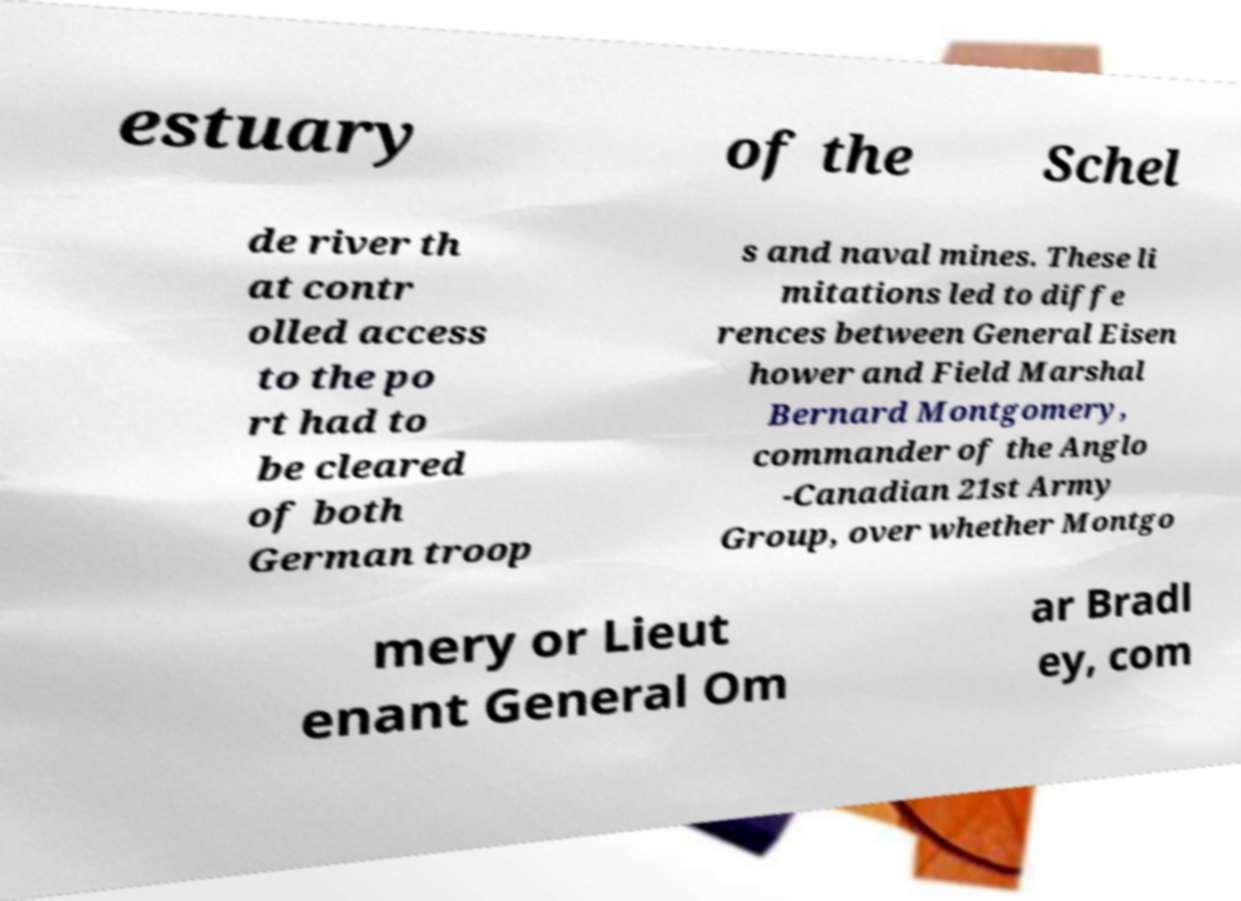What messages or text are displayed in this image? I need them in a readable, typed format. estuary of the Schel de river th at contr olled access to the po rt had to be cleared of both German troop s and naval mines. These li mitations led to diffe rences between General Eisen hower and Field Marshal Bernard Montgomery, commander of the Anglo -Canadian 21st Army Group, over whether Montgo mery or Lieut enant General Om ar Bradl ey, com 